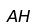<formula> <loc_0><loc_0><loc_500><loc_500>A H</formula> 